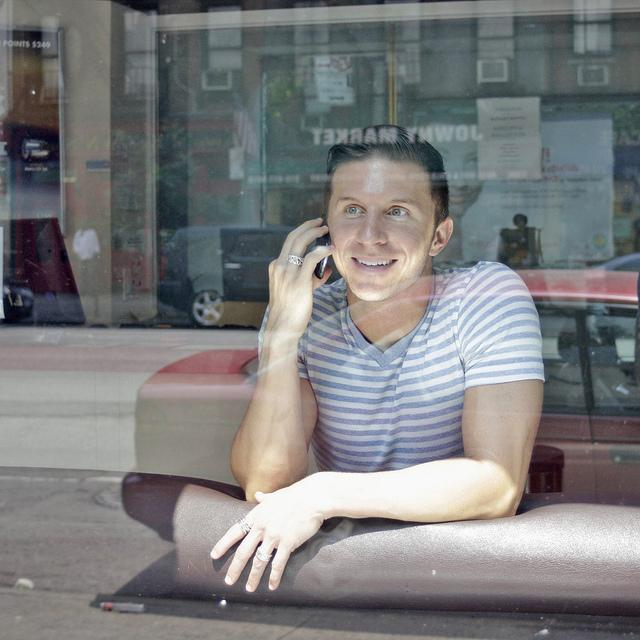What is the man on the phone sitting behind? window 